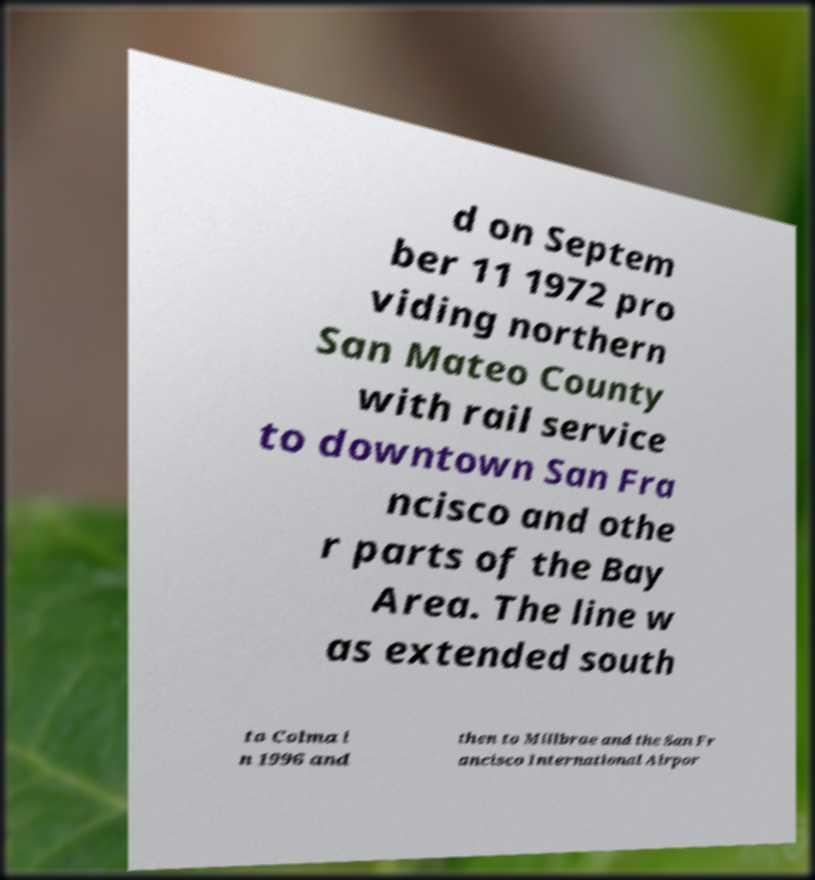Please read and relay the text visible in this image. What does it say? d on Septem ber 11 1972 pro viding northern San Mateo County with rail service to downtown San Fra ncisco and othe r parts of the Bay Area. The line w as extended south to Colma i n 1996 and then to Millbrae and the San Fr ancisco International Airpor 